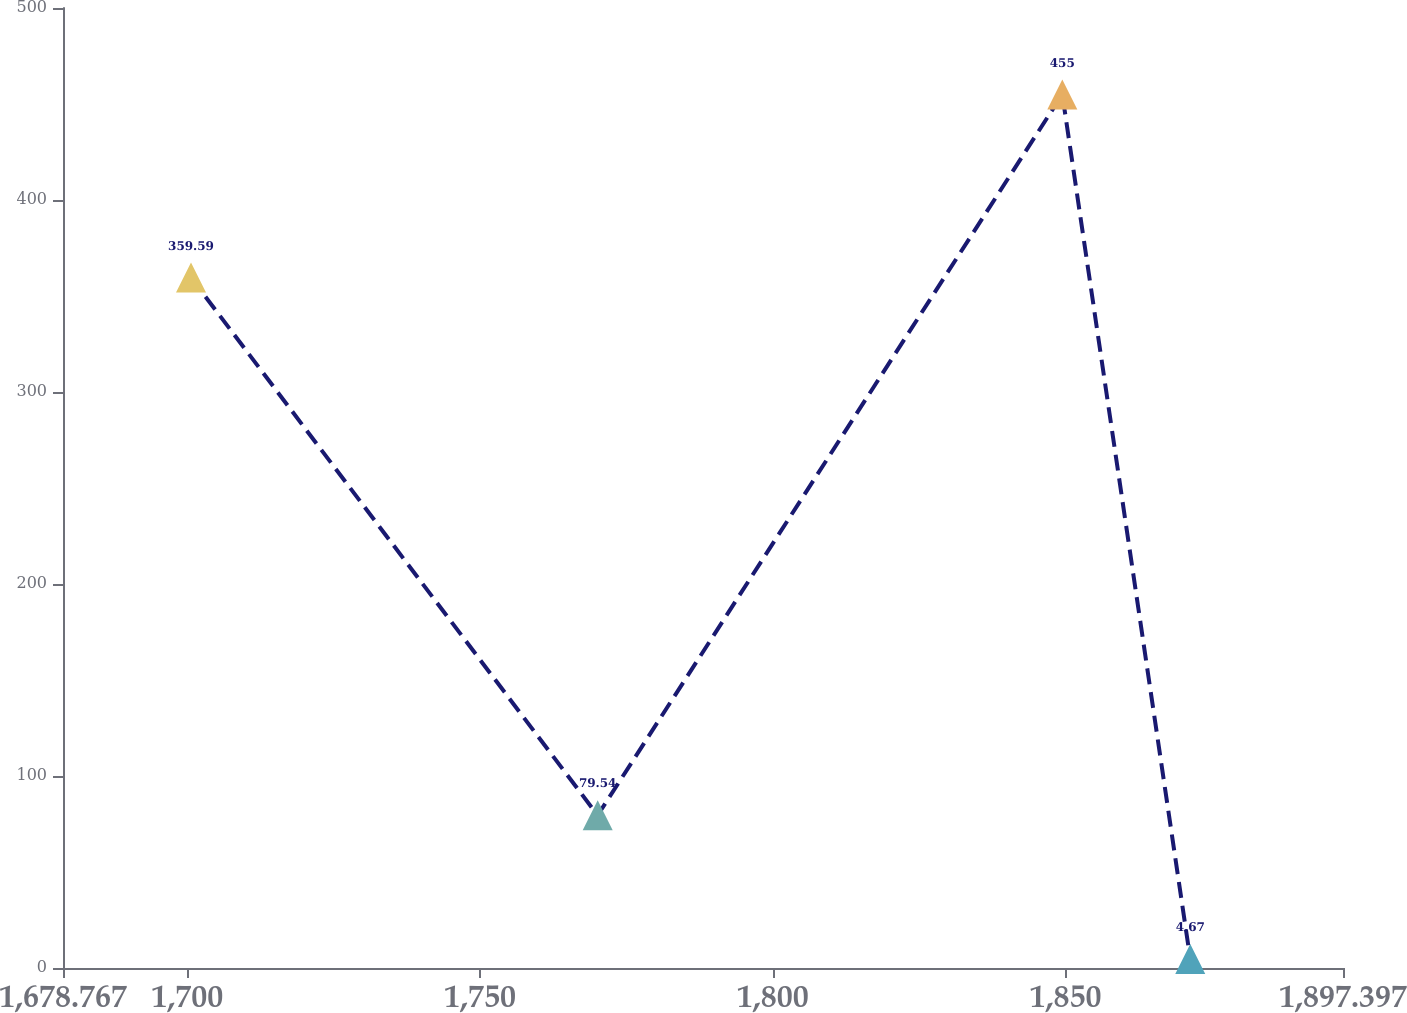Convert chart to OTSL. <chart><loc_0><loc_0><loc_500><loc_500><line_chart><ecel><fcel>Unnamed: 1<nl><fcel>1700.63<fcel>359.59<nl><fcel>1770.09<fcel>79.54<nl><fcel>1849.45<fcel>455<nl><fcel>1871.31<fcel>4.67<nl><fcel>1919.26<fcel>753.37<nl></chart> 